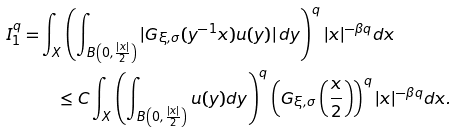Convert formula to latex. <formula><loc_0><loc_0><loc_500><loc_500>I ^ { q } _ { 1 } = & \int _ { X } \left ( \int _ { B \left ( 0 , \frac { | x | } { 2 } \right ) } | G _ { \xi , \sigma } ( y ^ { - 1 } x ) u ( y ) | \, d y \right ) ^ { q } | x | ^ { - \beta q } d x \\ & \quad \leq C \int _ { X } \left ( \int _ { B \left ( 0 , \frac { | x | } { 2 } \right ) } u ( y ) d y \right ) ^ { q } \left ( G _ { \xi , \sigma } \left ( \frac { x } { 2 } \right ) \right ) ^ { q } | x | ^ { - \beta q } d x .</formula> 